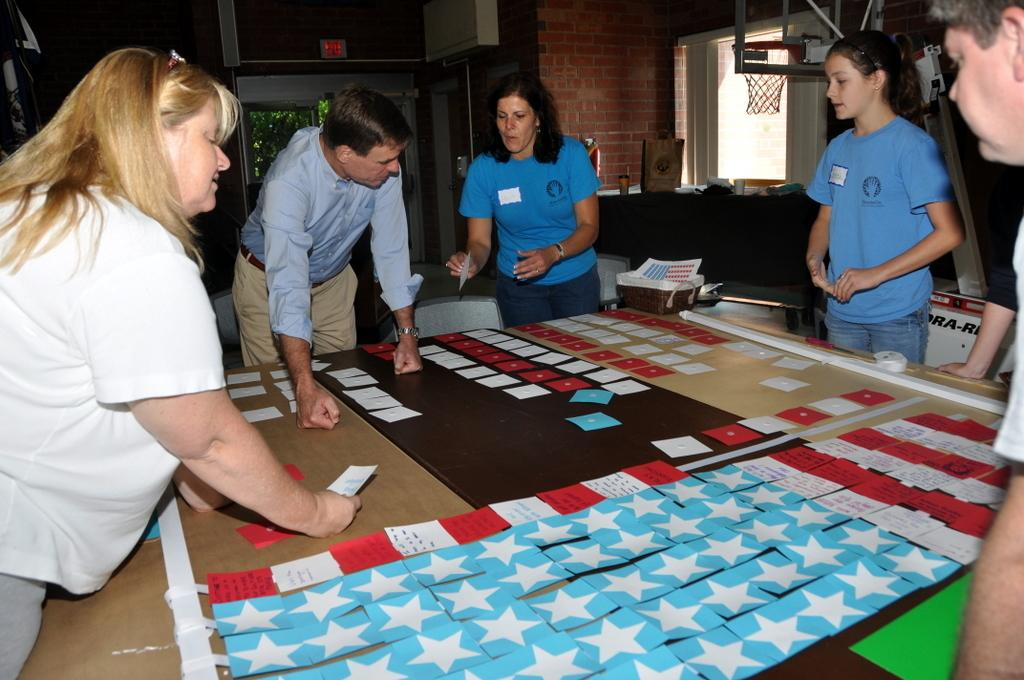What type of structure is visible in the image? There is a brick wall in the image. What architectural feature can be seen in the brick wall? There is a window in the image. What is hanging in the image? There is a net in the image. What are the people in the image doing? There are people standing around a table in the image. What is on the table in the image? There are papers on the table in the image. What type of headwear is worn by the people in the image? There is no mention of headwear or any clothing in the image; the focus is on the brick wall, window, net, people, and table. What is the people's stance on peace in the image? There is no indication of any political or social stance in the image; it simply shows people standing around a table with papers on it. 